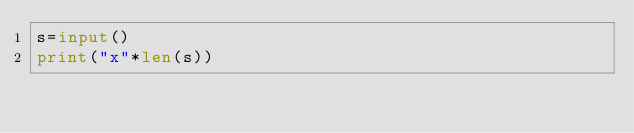<code> <loc_0><loc_0><loc_500><loc_500><_Python_>s=input()
print("x"*len(s))</code> 